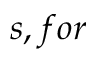Convert formula to latex. <formula><loc_0><loc_0><loc_500><loc_500>s , f o r</formula> 